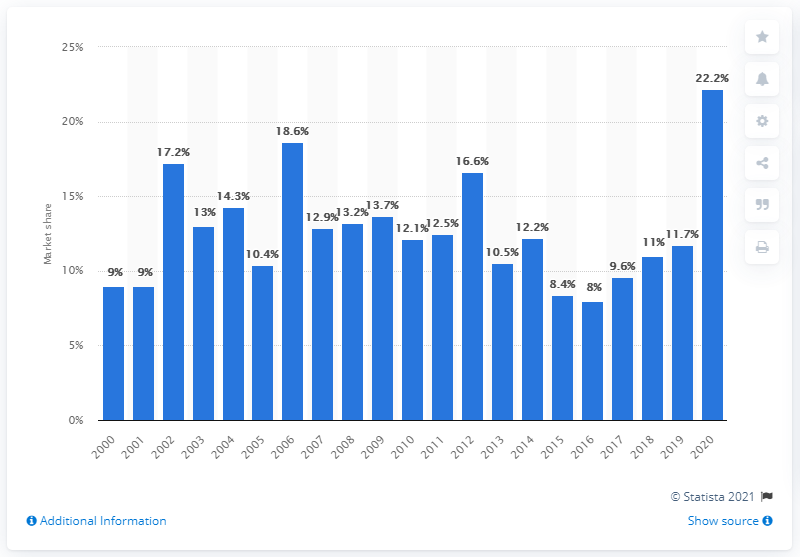Highlight a few significant elements in this photo. In 2020, Sony/Columbia films accounted for approximately 22.2% of the total earnings at the box office in North America. The amount of Sony/Columbia releases that increased from the previous year was 22.2.. 